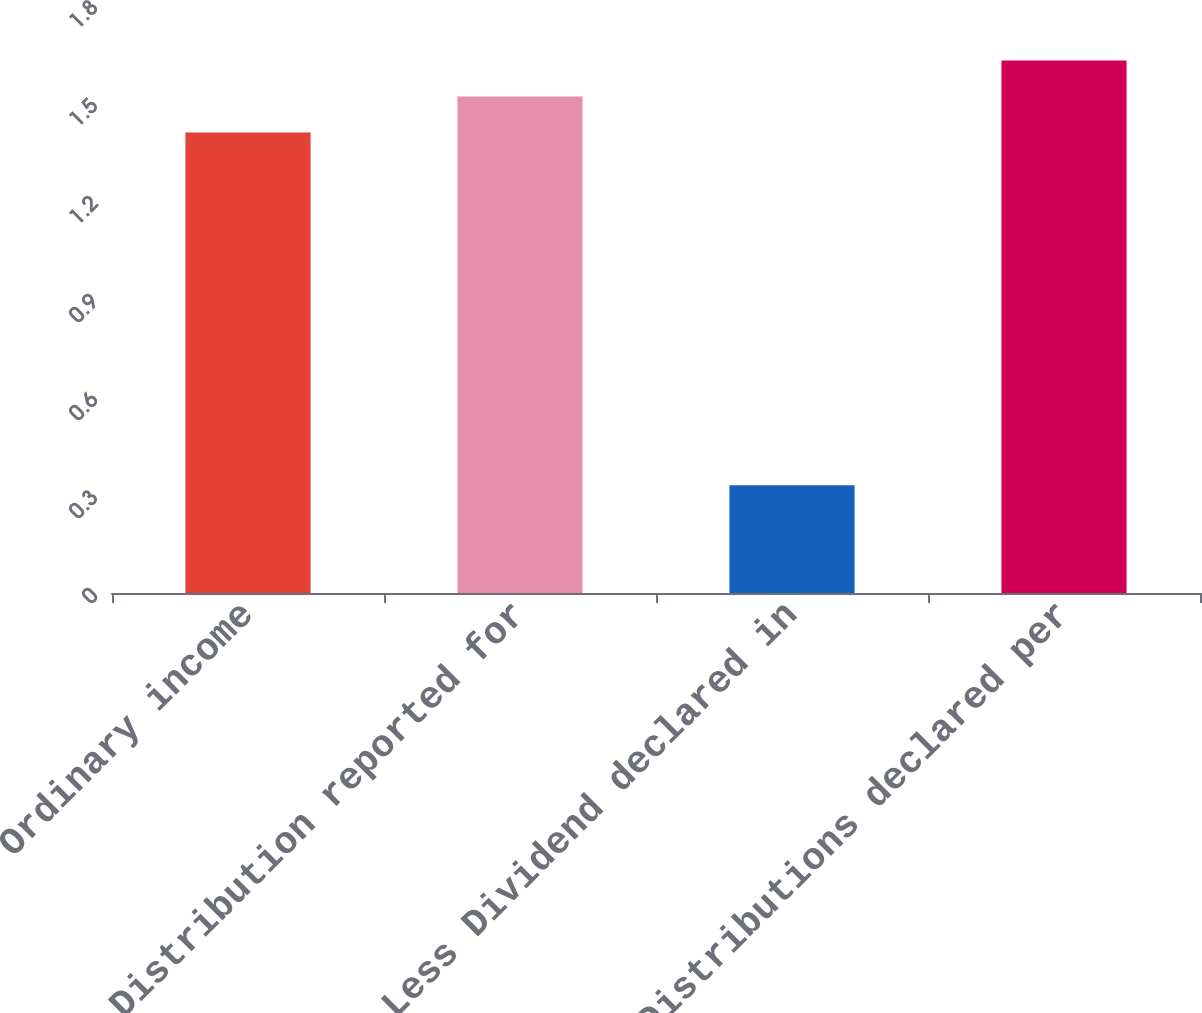Convert chart. <chart><loc_0><loc_0><loc_500><loc_500><bar_chart><fcel>Ordinary income<fcel>Distribution reported for<fcel>Less Dividend declared in<fcel>Distributions declared per<nl><fcel>1.41<fcel>1.52<fcel>0.33<fcel>1.63<nl></chart> 